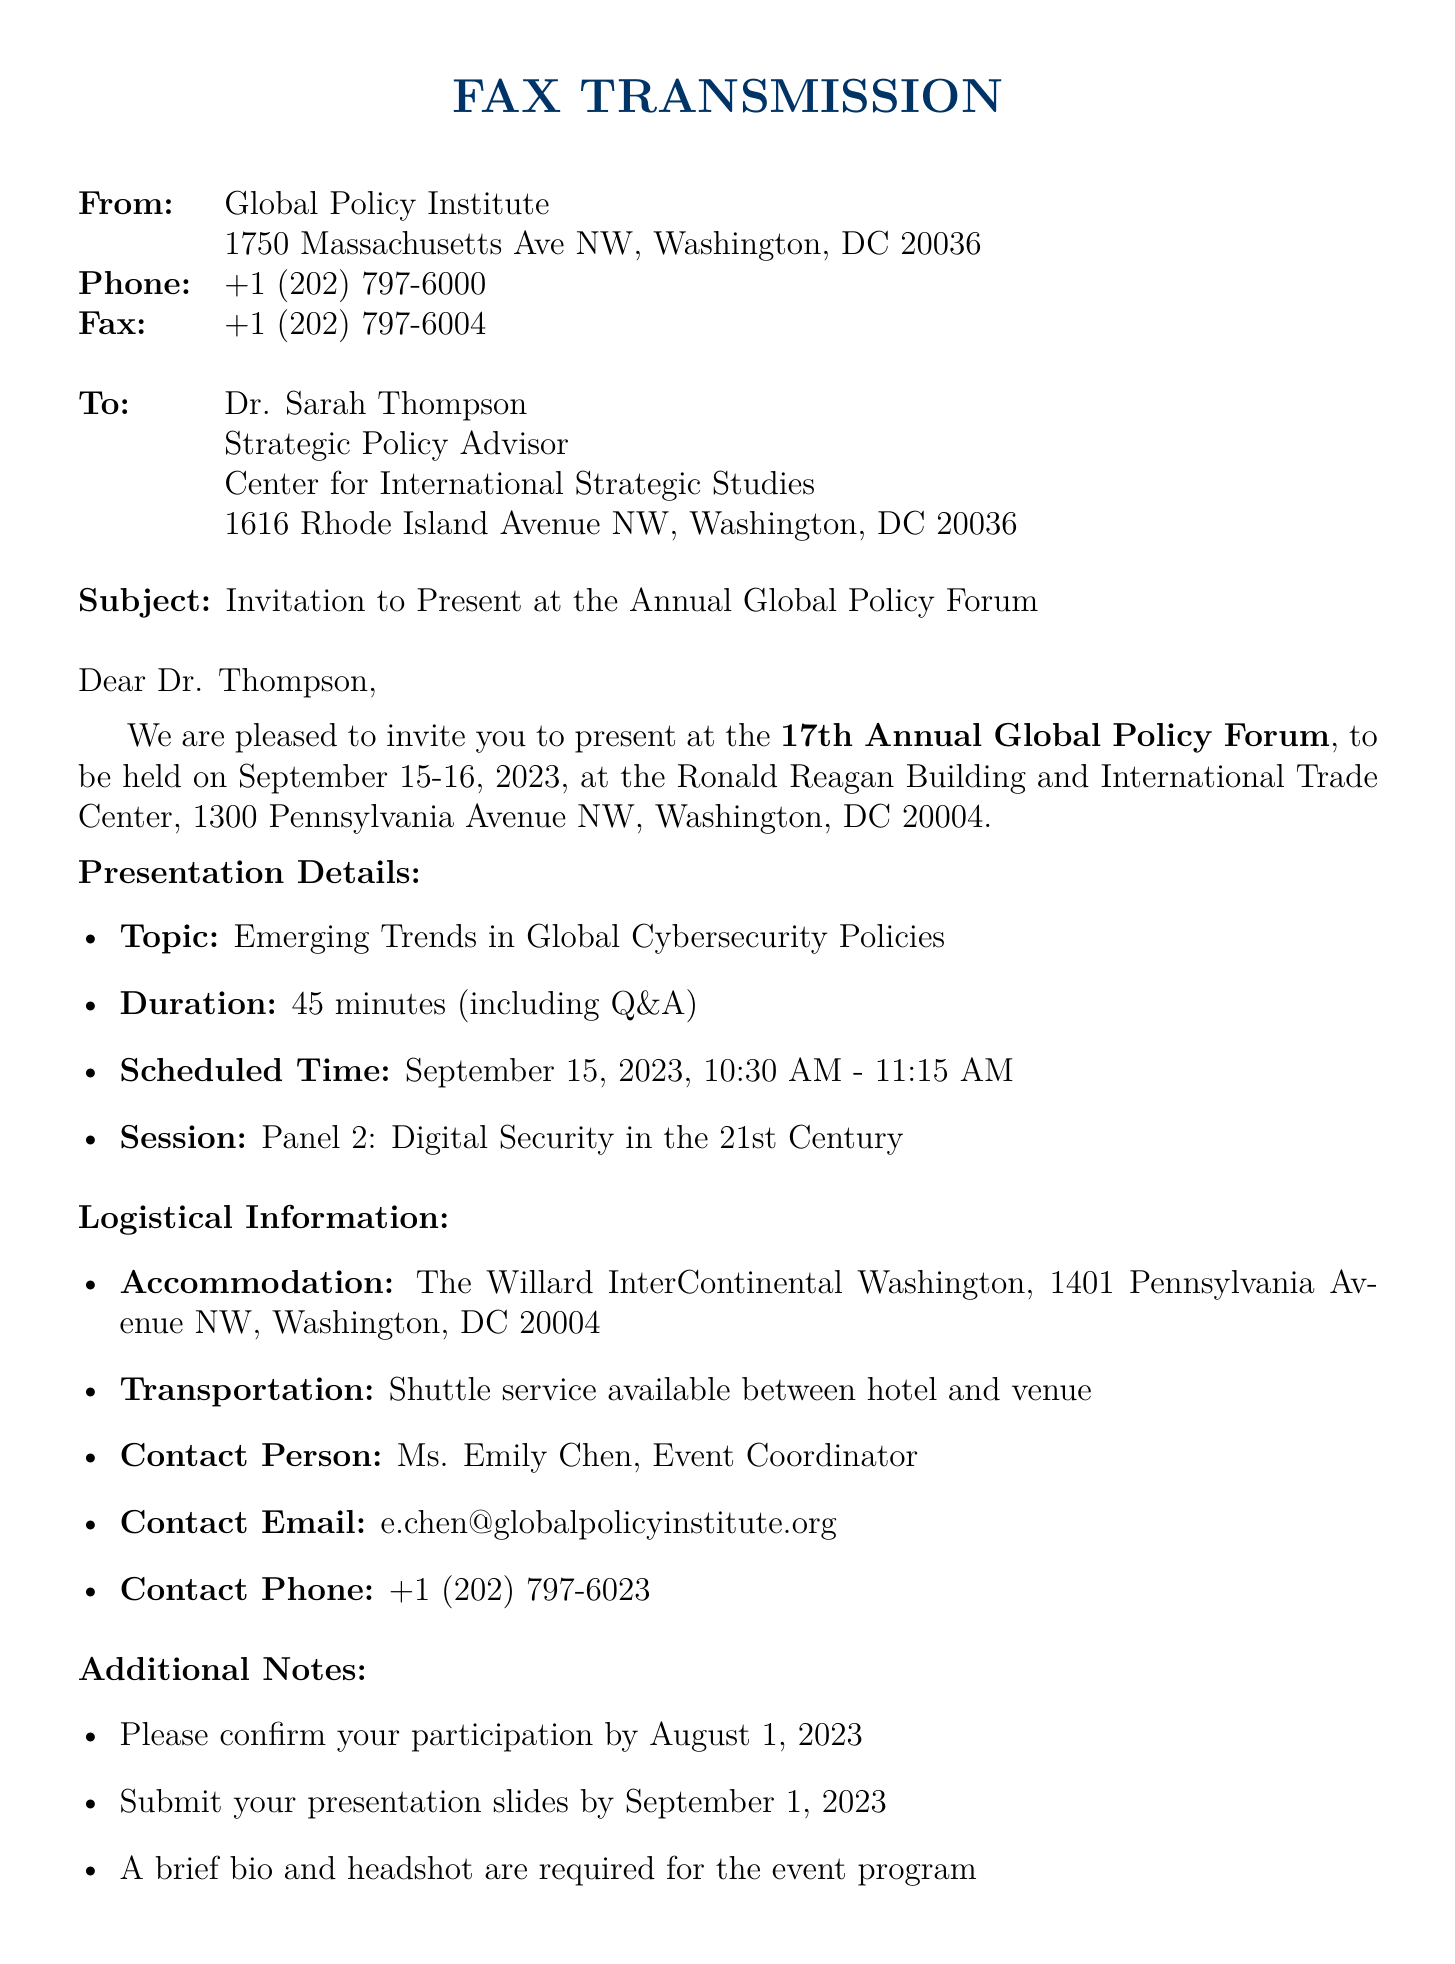what is the date of the forum? The document states that the forum will be held on September 15-16, 2023.
Answer: September 15-16, 2023 who is the contact person for the event? The document lists Ms. Emily Chen as the contact person for the event.
Answer: Ms. Emily Chen what is the scheduled time for the presentation? The presentation is scheduled for September 15, 2023, from 10:30 AM to 11:15 AM.
Answer: September 15, 2023, 10:30 AM - 11:15 AM what is the topic of the presentation? The topic mentioned in the document is "Emerging Trends in Global Cybersecurity Policies."
Answer: Emerging Trends in Global Cybersecurity Policies by when should the presentation slides be submitted? The document states that presentation slides should be submitted by September 1, 2023.
Answer: September 1, 2023 how long is the presentation duration? The document indicates that the duration of the presentation is 45 minutes.
Answer: 45 minutes what is the venue for the forum? The document specifies the venue as the Ronald Reagan Building and International Trade Center.
Answer: Ronald Reagan Building and International Trade Center what transportation option is available? According to the document, shuttle service is available between the hotel and venue.
Answer: Shuttle service what should be confirmed and by when? The document requests confirmation of participation by August 1, 2023.
Answer: Confirmation of participation by August 1, 2023 